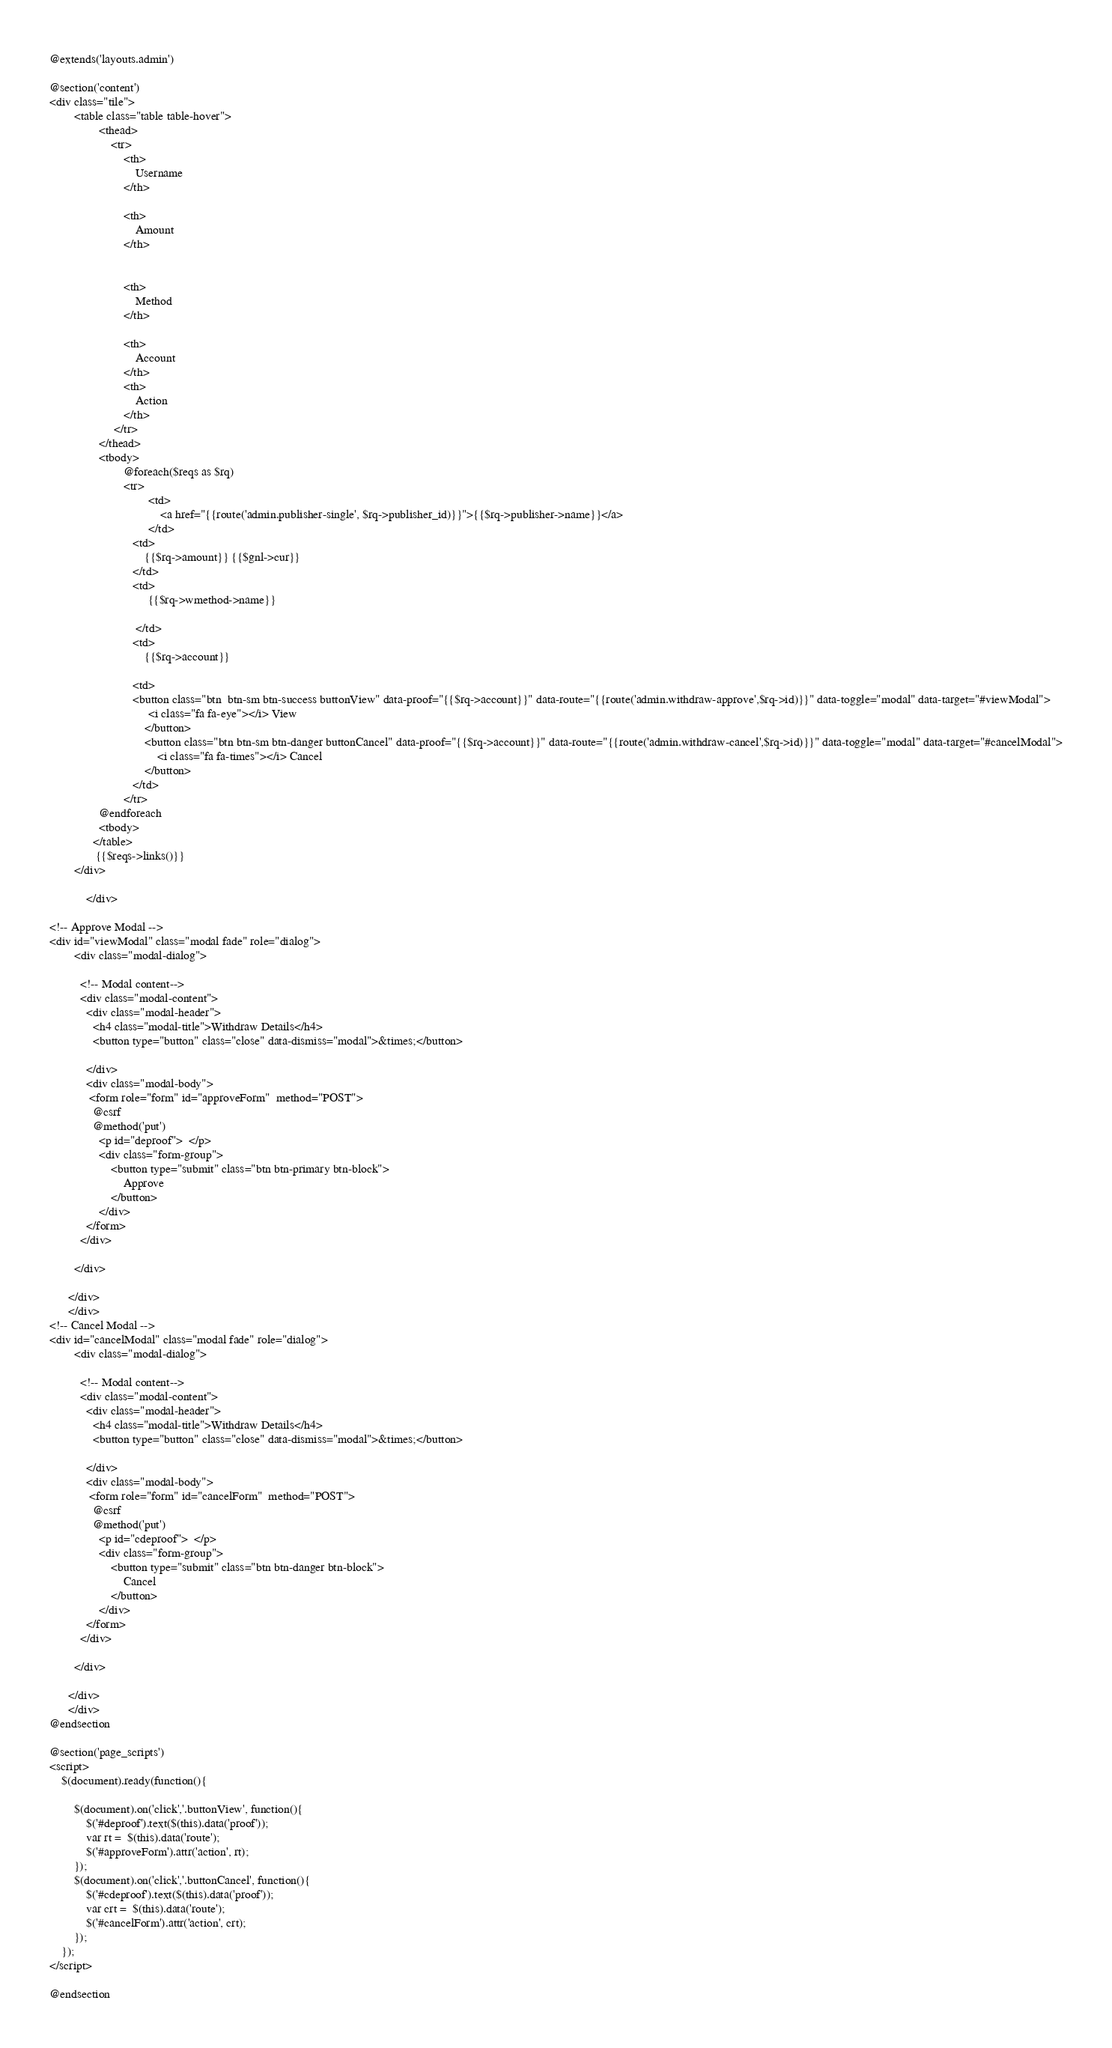<code> <loc_0><loc_0><loc_500><loc_500><_PHP_>@extends('layouts.admin')

@section('content')
<div class="tile">
        <table class="table table-hover">
                <thead>
                    <tr>
                        <th>
                            Username 
                        </th>

                        <th>
                            Amount
                        </th>
                    

                        <th>
                            Method
                        </th>
                    
                        <th>
                            Account
                        </th>         	
                        <th>
                            Action
                        </th>
                  	 </tr>
                </thead>
                <tbody>
                        @foreach($reqs as $rq)
                        <tr>
                                <td>
                                    <a href="{{route('admin.publisher-single', $rq->publisher_id)}}">{{$rq->publisher->name}}</a>
                                </td>
                           <td>
                               {{$rq->amount}} {{$gnl->cur}}      
                           </td> 
                           <td>
                                {{$rq->wmethod->name}}      
                                
                            </td>
                           <td>
                               {{$rq->account}}      
                         
                           <td>
                           <button class="btn  btn-sm btn-success buttonView" data-proof="{{$rq->account}}" data-route="{{route('admin.withdraw-approve',$rq->id)}}" data-toggle="modal" data-target="#viewModal">
                                <i class="fa fa-eye"></i> View 
                               </button>
                               <button class="btn btn-sm btn-danger buttonCancel" data-proof="{{$rq->account}}" data-route="{{route('admin.withdraw-cancel',$rq->id)}}" data-toggle="modal" data-target="#cancelModal">
                                   <i class="fa fa-times"></i> Cancel 
                               </button>
                           </td>
                        </tr>
                @endforeach 
                <tbody>
              </table>
               {{$reqs->links()}}
        </div>
			
			</div>
		
<!-- Approve Modal -->
<div id="viewModal" class="modal fade" role="dialog">
        <div class="modal-dialog">
      
          <!-- Modal content-->
          <div class="modal-content">
            <div class="modal-header">
              <h4 class="modal-title">Withdraw Details</h4>
              <button type="button" class="close" data-dismiss="modal">&times;</button>

            </div>
            <div class="modal-body">
             <form role="form" id="approveForm"  method="POST">
              @csrf
              @method('put')
                <p id="deproof">  </p>
                <div class="form-group">   
                    <button type="submit" class="btn btn-primary btn-block">
                        Approve
                    </button>
                </div>
            </form>
          </div>
      
        </div>
      
      </div>
      </div>
<!-- Cancel Modal -->
<div id="cancelModal" class="modal fade" role="dialog">
        <div class="modal-dialog">
      
          <!-- Modal content-->
          <div class="modal-content">
            <div class="modal-header">
              <h4 class="modal-title">Withdraw Details</h4>
              <button type="button" class="close" data-dismiss="modal">&times;</button>

            </div>
            <div class="modal-body">
             <form role="form" id="cancelForm"  method="POST">
              @csrf
              @method('put')
                <p id="cdeproof">  </p>
                <div class="form-group">   
                    <button type="submit" class="btn btn-danger btn-block">
                        Cancel
                    </button>
                </div>
            </form>
          </div>
      
        </div>
      
      </div>
      </div>
@endsection

@section('page_scripts')
<script>
    $(document).ready(function(){
        
        $(document).on('click','.buttonView', function(){
            $('#deproof').text($(this).data('proof'));
            var rt =  $(this).data('route');
            $('#approveForm').attr('action', rt);
        });
        $(document).on('click','.buttonCancel', function(){
            $('#cdeproof').text($(this).data('proof'));
            var crt =  $(this).data('route');
            $('#cancelForm').attr('action', crt);
        });
    });
</script>

@endsection</code> 